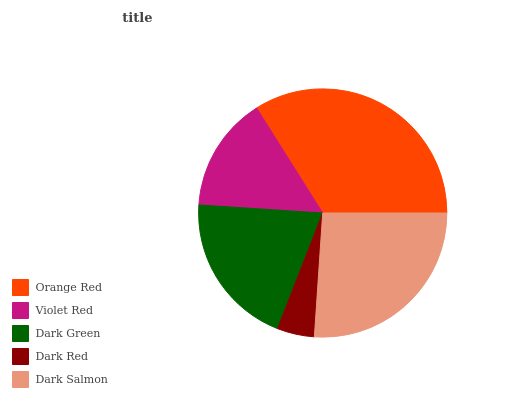Is Dark Red the minimum?
Answer yes or no. Yes. Is Orange Red the maximum?
Answer yes or no. Yes. Is Violet Red the minimum?
Answer yes or no. No. Is Violet Red the maximum?
Answer yes or no. No. Is Orange Red greater than Violet Red?
Answer yes or no. Yes. Is Violet Red less than Orange Red?
Answer yes or no. Yes. Is Violet Red greater than Orange Red?
Answer yes or no. No. Is Orange Red less than Violet Red?
Answer yes or no. No. Is Dark Green the high median?
Answer yes or no. Yes. Is Dark Green the low median?
Answer yes or no. Yes. Is Dark Salmon the high median?
Answer yes or no. No. Is Dark Salmon the low median?
Answer yes or no. No. 